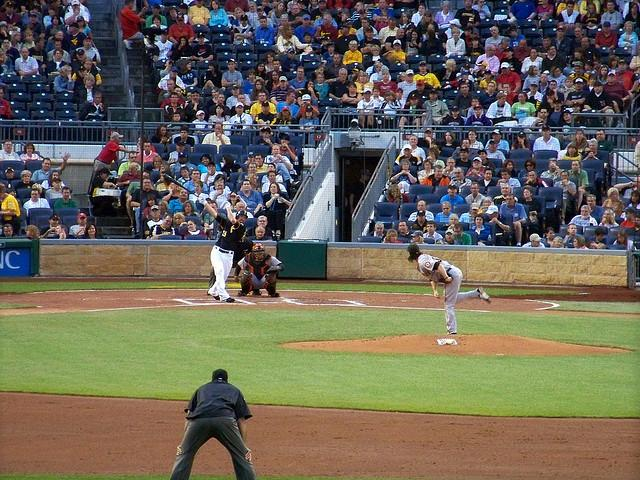What does the man in the center of the field want to achieve?

Choices:
A) home run
B) walk
C) foul
D) strike strike 